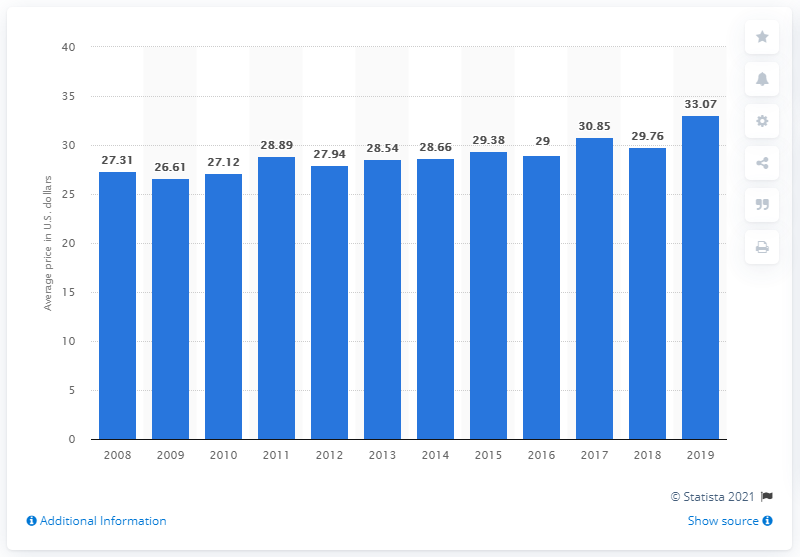Mention a couple of crucial points in this snapshot. The average price for a deluxe manicure in the United States from 2008 to 2019 was $33.07. The average price for a deluxe manicure in the United States from 2008 to 2019 was $33.07. 